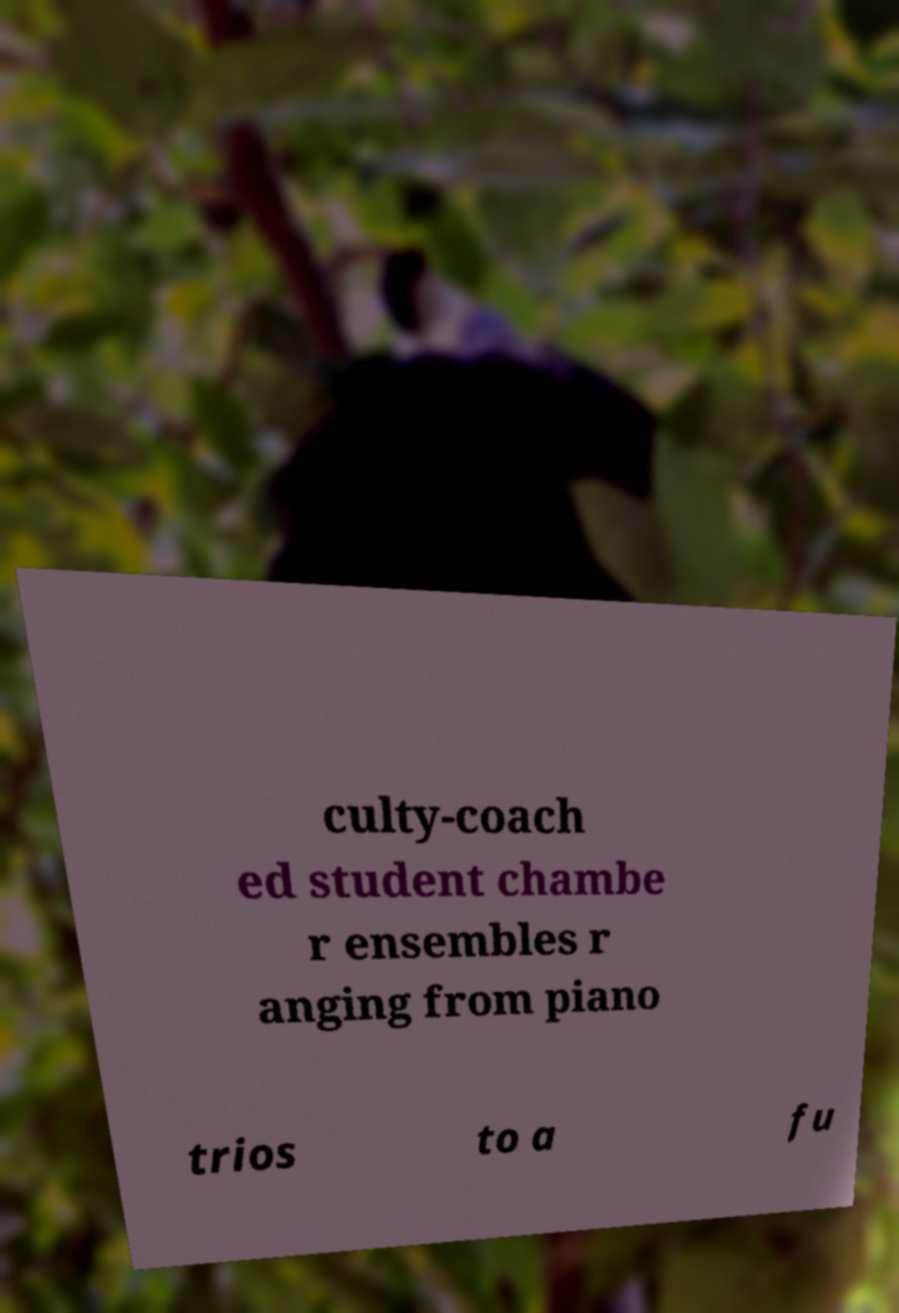Can you read and provide the text displayed in the image?This photo seems to have some interesting text. Can you extract and type it out for me? culty-coach ed student chambe r ensembles r anging from piano trios to a fu 